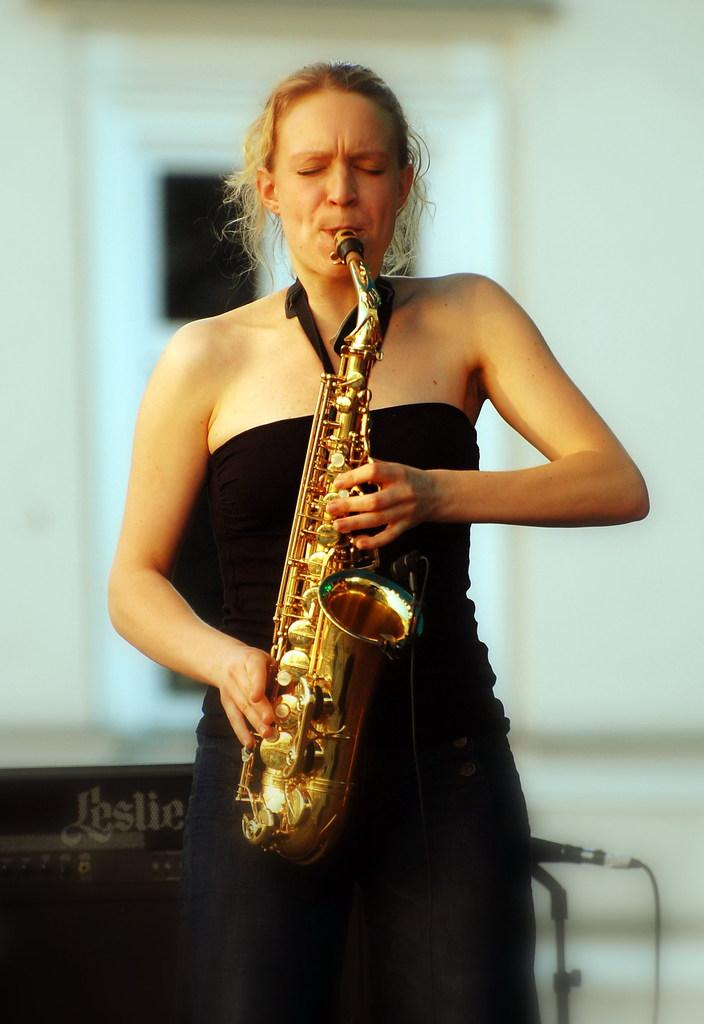Who is the main subject in the image? There is a woman in the image. What is the woman doing in the image? The woman is playing a musical instrument. What can be seen in the background of the image? There is a white color wall in the background of the image. How many boats are visible in the image? There are no boats present in the image. Is there a fan visible in the image? There is no fan present in the image. 